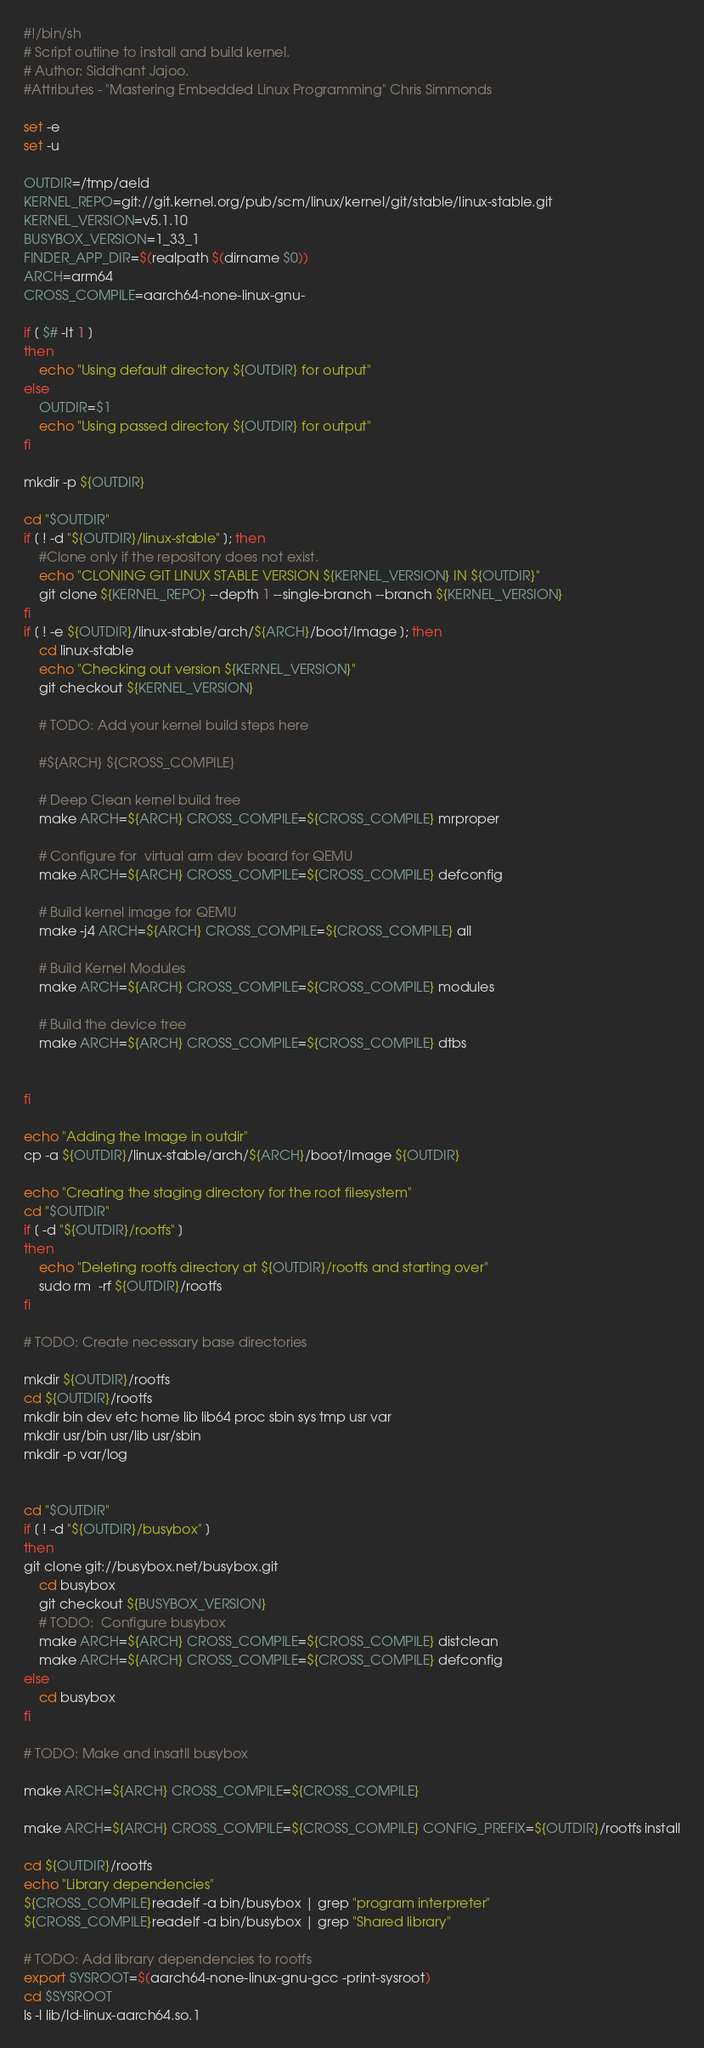Convert code to text. <code><loc_0><loc_0><loc_500><loc_500><_Bash_>#!/bin/sh
# Script outline to install and build kernel.
# Author: Siddhant Jajoo.
#Attributes - "Mastering Embedded Linux Programming" Chris Simmonds

set -e
set -u

OUTDIR=/tmp/aeld
KERNEL_REPO=git://git.kernel.org/pub/scm/linux/kernel/git/stable/linux-stable.git
KERNEL_VERSION=v5.1.10
BUSYBOX_VERSION=1_33_1
FINDER_APP_DIR=$(realpath $(dirname $0))
ARCH=arm64
CROSS_COMPILE=aarch64-none-linux-gnu-

if [ $# -lt 1 ]
then
	echo "Using default directory ${OUTDIR} for output"
else
	OUTDIR=$1
	echo "Using passed directory ${OUTDIR} for output"
fi

mkdir -p ${OUTDIR}

cd "$OUTDIR"
if [ ! -d "${OUTDIR}/linux-stable" ]; then
    #Clone only if the repository does not exist.
	echo "CLONING GIT LINUX STABLE VERSION ${KERNEL_VERSION} IN ${OUTDIR}"
	git clone ${KERNEL_REPO} --depth 1 --single-branch --branch ${KERNEL_VERSION}
fi
if [ ! -e ${OUTDIR}/linux-stable/arch/${ARCH}/boot/Image ]; then
    cd linux-stable
    echo "Checking out version ${KERNEL_VERSION}"
    git checkout ${KERNEL_VERSION}

    # TODO: Add your kernel build steps here

    #${ARCH} ${CROSS_COMPILE}

    # Deep Clean kernel build tree
    make ARCH=${ARCH} CROSS_COMPILE=${CROSS_COMPILE} mrproper

    # Configure for  virtual arm dev board for QEMU
    make ARCH=${ARCH} CROSS_COMPILE=${CROSS_COMPILE} defconfig

    # Build kernel image for QEMU
    make -j4 ARCH=${ARCH} CROSS_COMPILE=${CROSS_COMPILE} all

    # Build Kernel Modules
    make ARCH=${ARCH} CROSS_COMPILE=${CROSS_COMPILE} modules

    # Build the device tree
    make ARCH=${ARCH} CROSS_COMPILE=${CROSS_COMPILE} dtbs


fi 

echo "Adding the Image in outdir"
cp -a ${OUTDIR}/linux-stable/arch/${ARCH}/boot/Image ${OUTDIR}

echo "Creating the staging directory for the root filesystem"
cd "$OUTDIR"
if [ -d "${OUTDIR}/rootfs" ]
then
	echo "Deleting rootfs directory at ${OUTDIR}/rootfs and starting over"
    sudo rm  -rf ${OUTDIR}/rootfs
fi

# TODO: Create necessary base directories

mkdir ${OUTDIR}/rootfs
cd ${OUTDIR}/rootfs
mkdir bin dev etc home lib lib64 proc sbin sys tmp usr var
mkdir usr/bin usr/lib usr/sbin
mkdir -p var/log


cd "$OUTDIR"
if [ ! -d "${OUTDIR}/busybox" ]
then
git clone git://busybox.net/busybox.git
    cd busybox
    git checkout ${BUSYBOX_VERSION}
    # TODO:  Configure busybox
    make ARCH=${ARCH} CROSS_COMPILE=${CROSS_COMPILE} distclean
    make ARCH=${ARCH} CROSS_COMPILE=${CROSS_COMPILE} defconfig
else
    cd busybox
fi

# TODO: Make and insatll busybox

make ARCH=${ARCH} CROSS_COMPILE=${CROSS_COMPILE}

make ARCH=${ARCH} CROSS_COMPILE=${CROSS_COMPILE} CONFIG_PREFIX=${OUTDIR}/rootfs install

cd ${OUTDIR}/rootfs
echo "Library dependencies"
${CROSS_COMPILE}readelf -a bin/busybox | grep "program interpreter"
${CROSS_COMPILE}readelf -a bin/busybox | grep "Shared library"

# TODO: Add library dependencies to rootfs
export SYSROOT=$(aarch64-none-linux-gnu-gcc -print-sysroot)
cd $SYSROOT
ls -l lib/ld-linux-aarch64.so.1</code> 